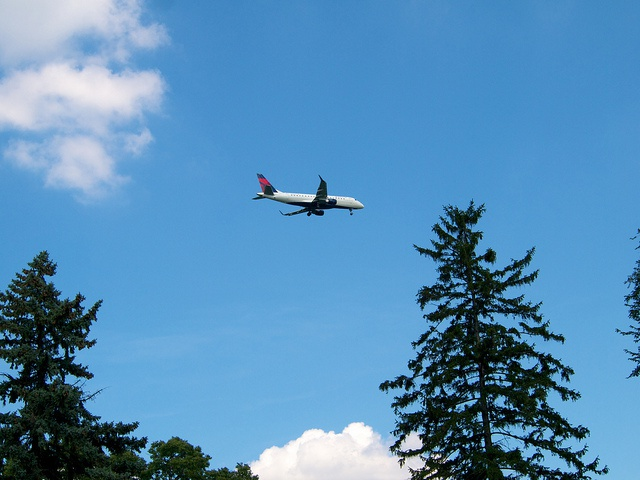Describe the objects in this image and their specific colors. I can see a airplane in lightgray, black, darkgray, and gray tones in this image. 